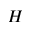<formula> <loc_0><loc_0><loc_500><loc_500>H</formula> 